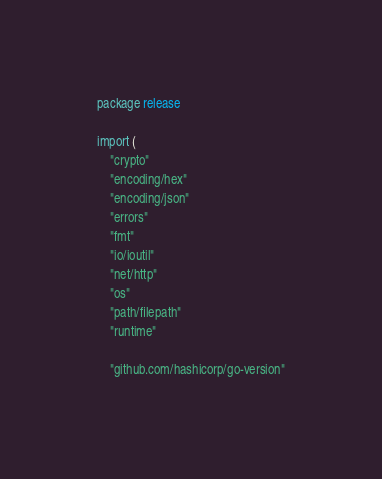Convert code to text. <code><loc_0><loc_0><loc_500><loc_500><_Go_>package release

import (
	"crypto"
	"encoding/hex"
	"encoding/json"
	"errors"
	"fmt"
	"io/ioutil"
	"net/http"
	"os"
	"path/filepath"
	"runtime"

	"github.com/hashicorp/go-version"</code> 